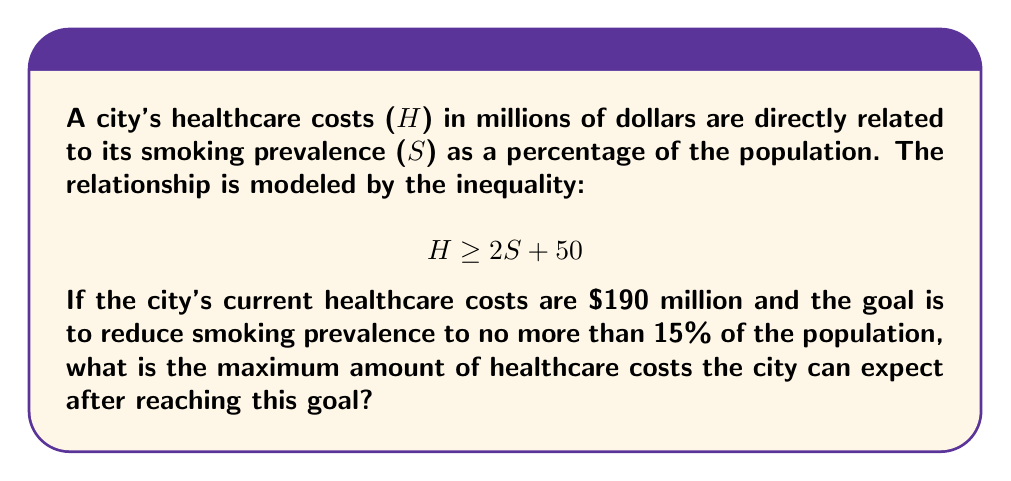Show me your answer to this math problem. 1. We start with the inequality: $$H \geq 2S + 50$$

2. We want to find the maximum healthcare costs when S = 15% (the goal):
   $$H \geq 2(15) + 50$$

3. Simplify:
   $$H \geq 30 + 50$$
   $$H \geq 80$$

4. This means that when smoking prevalence is reduced to 15%, the healthcare costs will be at least $80 million.

5. Since we're asked for the maximum amount, we use the equality:
   $$H = 80$$

6. Therefore, the maximum healthcare costs the city can expect after reaching the goal of 15% smoking prevalence is $80 million.
Answer: $80 million 